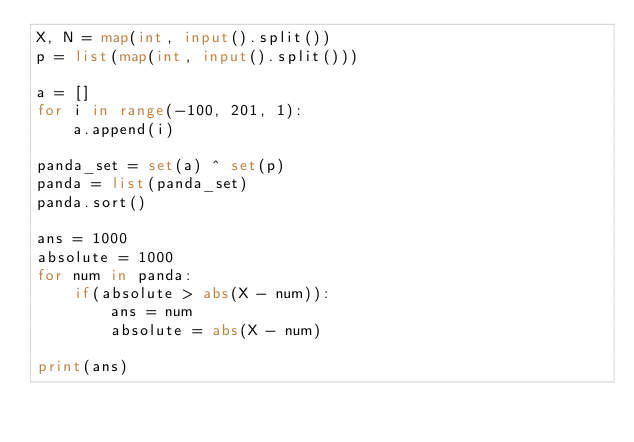<code> <loc_0><loc_0><loc_500><loc_500><_Python_>X, N = map(int, input().split())
p = list(map(int, input().split()))

a = []
for i in range(-100, 201, 1):
    a.append(i)

panda_set = set(a) ^ set(p)
panda = list(panda_set)
panda.sort()

ans = 1000
absolute = 1000
for num in panda:
    if(absolute > abs(X - num)):
        ans = num
        absolute = abs(X - num)

print(ans)</code> 